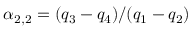Convert formula to latex. <formula><loc_0><loc_0><loc_500><loc_500>\alpha _ { 2 , 2 } = ( q _ { 3 } - q _ { 4 } ) / ( q _ { 1 } - q _ { 2 } )</formula> 